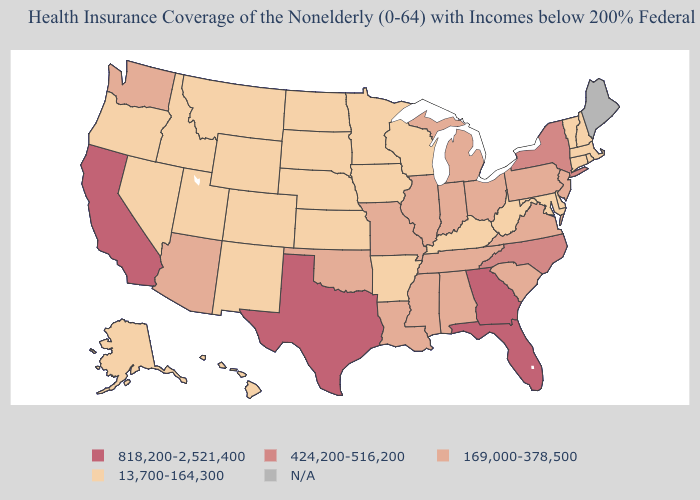How many symbols are there in the legend?
Write a very short answer. 5. Among the states that border Texas , which have the lowest value?
Be succinct. Arkansas, New Mexico. What is the value of Missouri?
Concise answer only. 169,000-378,500. Does the map have missing data?
Write a very short answer. Yes. Which states have the highest value in the USA?
Give a very brief answer. California, Florida, Georgia, Texas. Which states have the lowest value in the South?
Be succinct. Arkansas, Delaware, Kentucky, Maryland, West Virginia. Name the states that have a value in the range N/A?
Be succinct. Maine. Name the states that have a value in the range 169,000-378,500?
Give a very brief answer. Alabama, Arizona, Illinois, Indiana, Louisiana, Michigan, Mississippi, Missouri, New Jersey, Ohio, Oklahoma, Pennsylvania, South Carolina, Tennessee, Virginia, Washington. What is the lowest value in the South?
Keep it brief. 13,700-164,300. Does Wyoming have the lowest value in the USA?
Quick response, please. Yes. Name the states that have a value in the range 13,700-164,300?
Short answer required. Alaska, Arkansas, Colorado, Connecticut, Delaware, Hawaii, Idaho, Iowa, Kansas, Kentucky, Maryland, Massachusetts, Minnesota, Montana, Nebraska, Nevada, New Hampshire, New Mexico, North Dakota, Oregon, Rhode Island, South Dakota, Utah, Vermont, West Virginia, Wisconsin, Wyoming. 